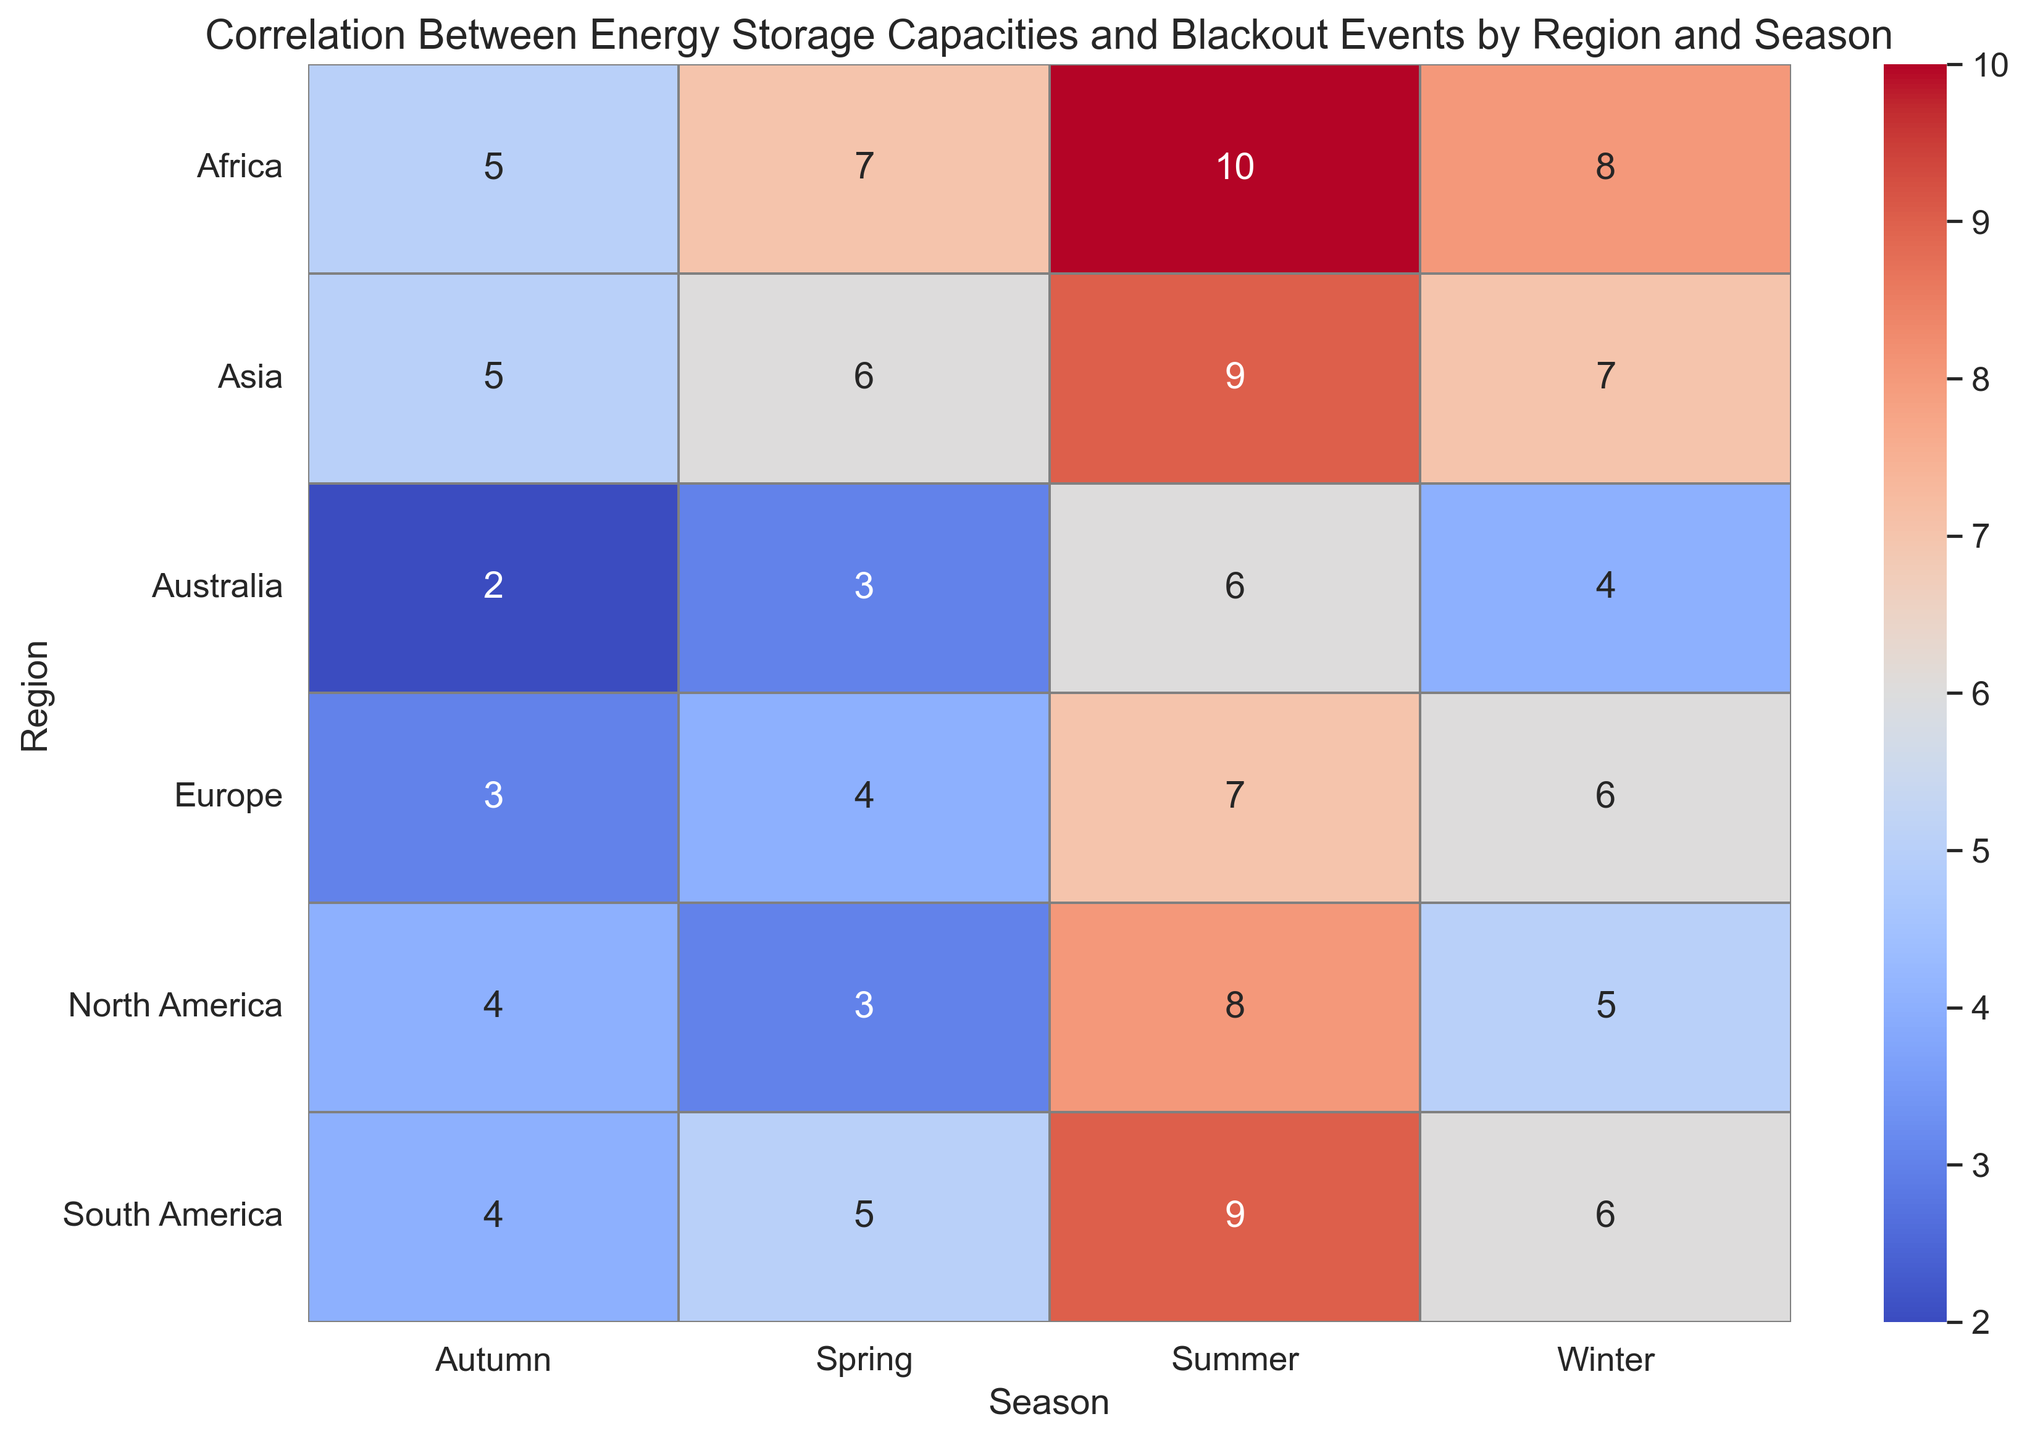Which region has the highest number of blackout events in the winter season? Look at the Winter column and identify the region with the darkest shade, which represents the highest number of blackout events.
Answer: Asia Which season in Africa has the least number of blackout events, and what is that number? Check the rows in the Africa column to see which season (Autumn, Winter, Spring, Summer) has the lightest shade indicating the lowest number.
Answer: Autumn, 5 Compare Europe and North America: which region experiences fewer blackout events in the summer? Compare the values for Europe and North America's rows in the Summer column. The region with the lighter shade (lower number) has fewer events.
Answer: Europe Considering only the Winter season, which region has the second-highest number of blackout events? List regions by the number of blackout events in Winter in descending order and pick the second value.
Answer: South America For the Spring season, what is the total number of blackout events across all regions? Sum all the values in the Spring column. The total is 6 (North America) + 4 (Europe) + 6 (Asia) + 3 (Australia) + 7 (Africa) + 5 (South America).
Answer: 31 Which season has more blackout events on average, Spring or Autumn, in North America? Calculate the average for both Spring and Autumn from North America's respective values (3 and 4, respectively).
Answer: Autumn What is the difference in the number of blackout events between Summer and Autumn in Asia? Subtract the number of blackout events in Autumn from those in Summer in the Asia row.
Answer: 4 Which region has the most consistent number of blackout events across the four seasons? Identify the region with the least variance in blackout event numbers by visually comparing the shades across all seasons for each region.
Answer: Australia In which season does South America experience more blackout events than both Africa and Australia? Compare blackout events for each season where South America’s value is greater than those of both Africa and Australia.
Answer: Winter What's the total number of blackout events in Australia throughout all seasons? Sum all the values in the Australia row (4 for Winter, 3 for Spring, 6 for Summer, 2 for Autumn).
Answer: 15 